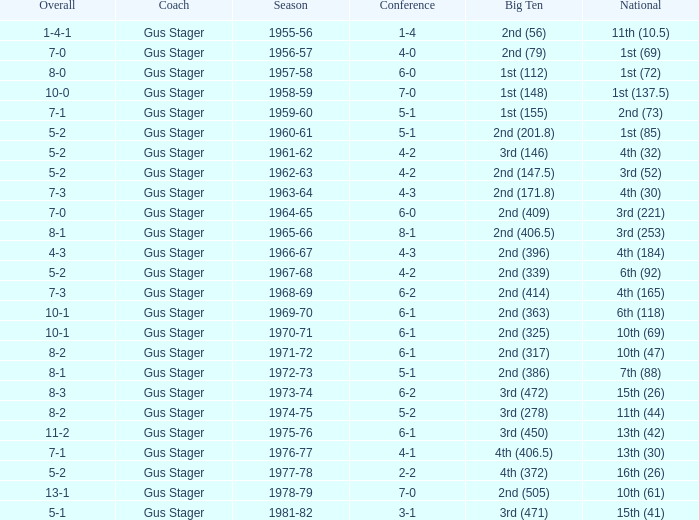What is the Coach with a Big Ten that is 1st (148)? Gus Stager. 